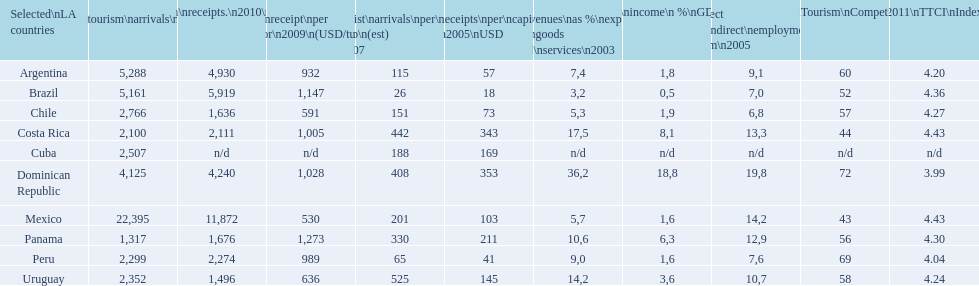What is the name of the country that had the most international tourism arrivals in 2010? Mexico. 